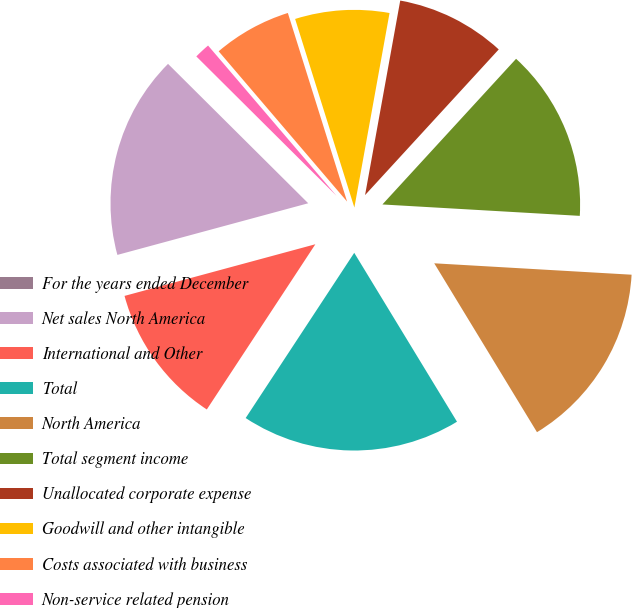Convert chart to OTSL. <chart><loc_0><loc_0><loc_500><loc_500><pie_chart><fcel>For the years ended December<fcel>Net sales North America<fcel>International and Other<fcel>Total<fcel>North America<fcel>Total segment income<fcel>Unallocated corporate expense<fcel>Goodwill and other intangible<fcel>Costs associated with business<fcel>Non-service related pension<nl><fcel>0.0%<fcel>16.66%<fcel>11.54%<fcel>17.95%<fcel>15.38%<fcel>14.1%<fcel>8.97%<fcel>7.69%<fcel>6.41%<fcel>1.29%<nl></chart> 